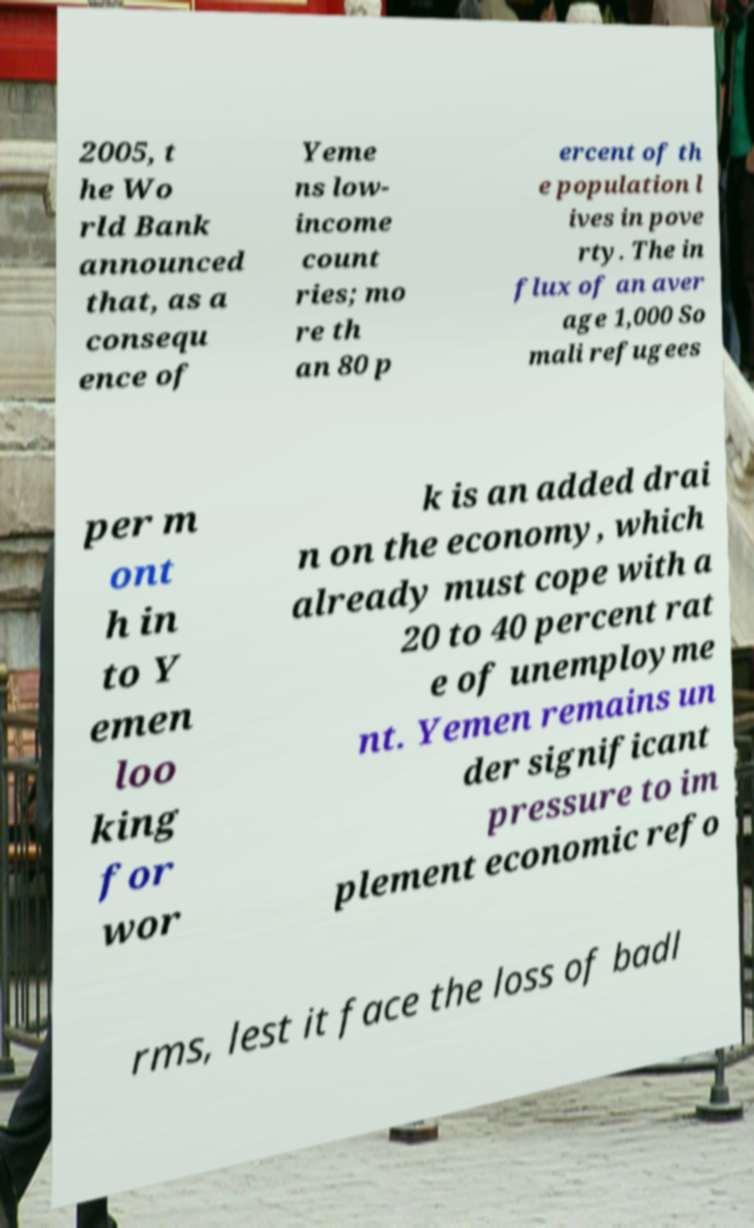For documentation purposes, I need the text within this image transcribed. Could you provide that? 2005, t he Wo rld Bank announced that, as a consequ ence of Yeme ns low- income count ries; mo re th an 80 p ercent of th e population l ives in pove rty. The in flux of an aver age 1,000 So mali refugees per m ont h in to Y emen loo king for wor k is an added drai n on the economy, which already must cope with a 20 to 40 percent rat e of unemployme nt. Yemen remains un der significant pressure to im plement economic refo rms, lest it face the loss of badl 